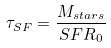<formula> <loc_0><loc_0><loc_500><loc_500>\tau _ { S F } = \frac { M _ { s t a r s } } { S F R _ { 0 } }</formula> 